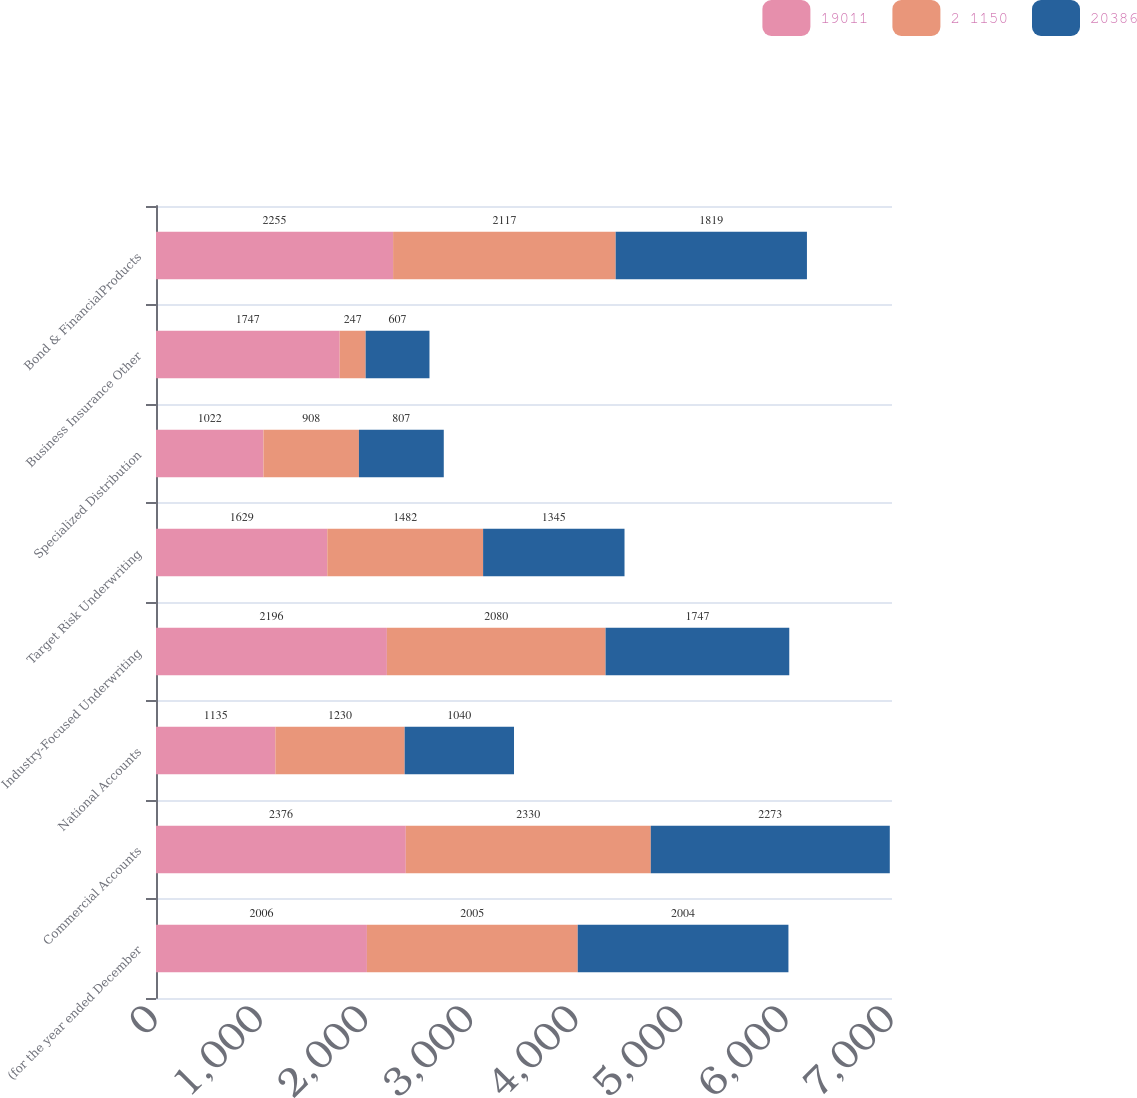<chart> <loc_0><loc_0><loc_500><loc_500><stacked_bar_chart><ecel><fcel>(for the year ended December<fcel>Commercial Accounts<fcel>National Accounts<fcel>Industry-Focused Underwriting<fcel>Target Risk Underwriting<fcel>Specialized Distribution<fcel>Business Insurance Other<fcel>Bond & FinancialProducts<nl><fcel>19011<fcel>2006<fcel>2376<fcel>1135<fcel>2196<fcel>1629<fcel>1022<fcel>1747<fcel>2255<nl><fcel>2 1150<fcel>2005<fcel>2330<fcel>1230<fcel>2080<fcel>1482<fcel>908<fcel>247<fcel>2117<nl><fcel>20386<fcel>2004<fcel>2273<fcel>1040<fcel>1747<fcel>1345<fcel>807<fcel>607<fcel>1819<nl></chart> 